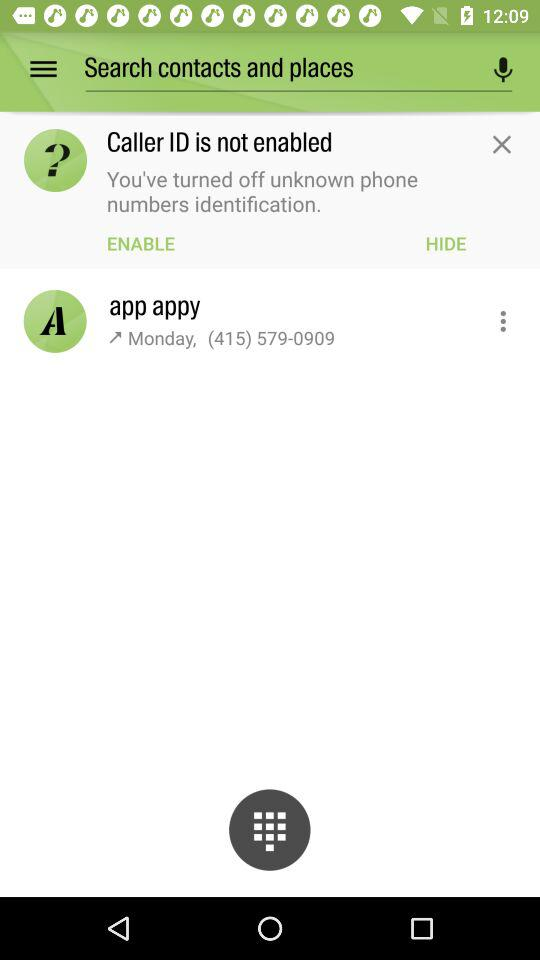What is the phone number of App Appy? The phone number of App Appy is (415) 579-0909. 